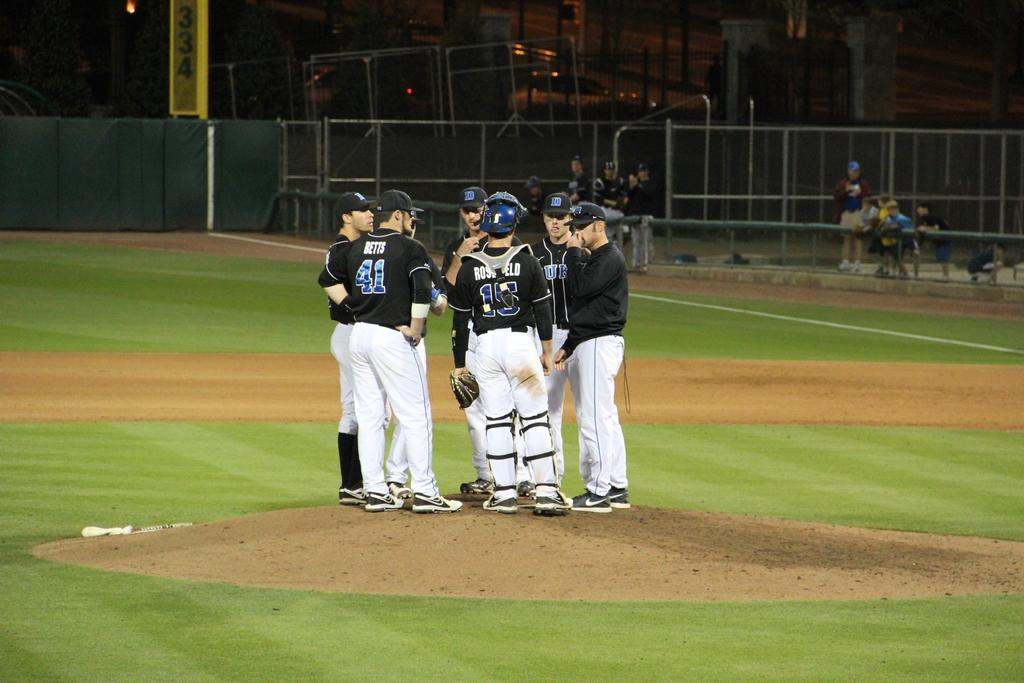Provide a one-sentence caption for the provided image. One of the sevral players on the field has the number 41 on his back. 